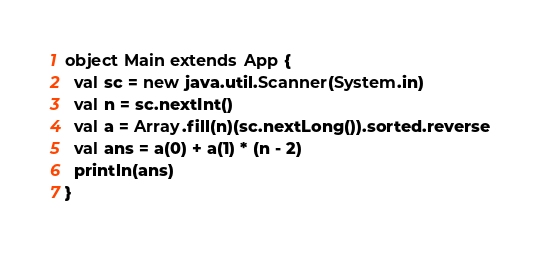Convert code to text. <code><loc_0><loc_0><loc_500><loc_500><_Scala_>object Main extends App {
  val sc = new java.util.Scanner(System.in)
  val n = sc.nextInt()
  val a = Array.fill(n)(sc.nextLong()).sorted.reverse
  val ans = a(0) + a(1) * (n - 2)
  println(ans)
}
</code> 